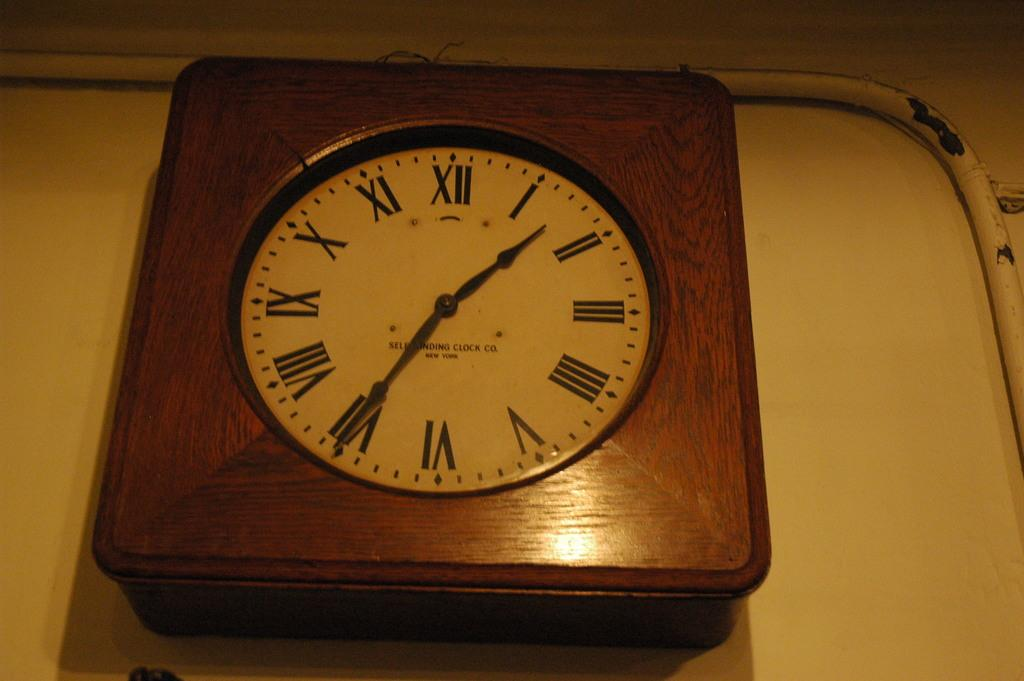What is present on the wall in the image? There is a pipe and a clock on the wall in the image. Can you describe the pipe on the wall? The pipe on the wall is a long, cylindrical object. What else is attached to the wall in the image? There is a clock on the wall. How many kittens are playing with the box in the image? There are no kittens or boxes present in the image. 